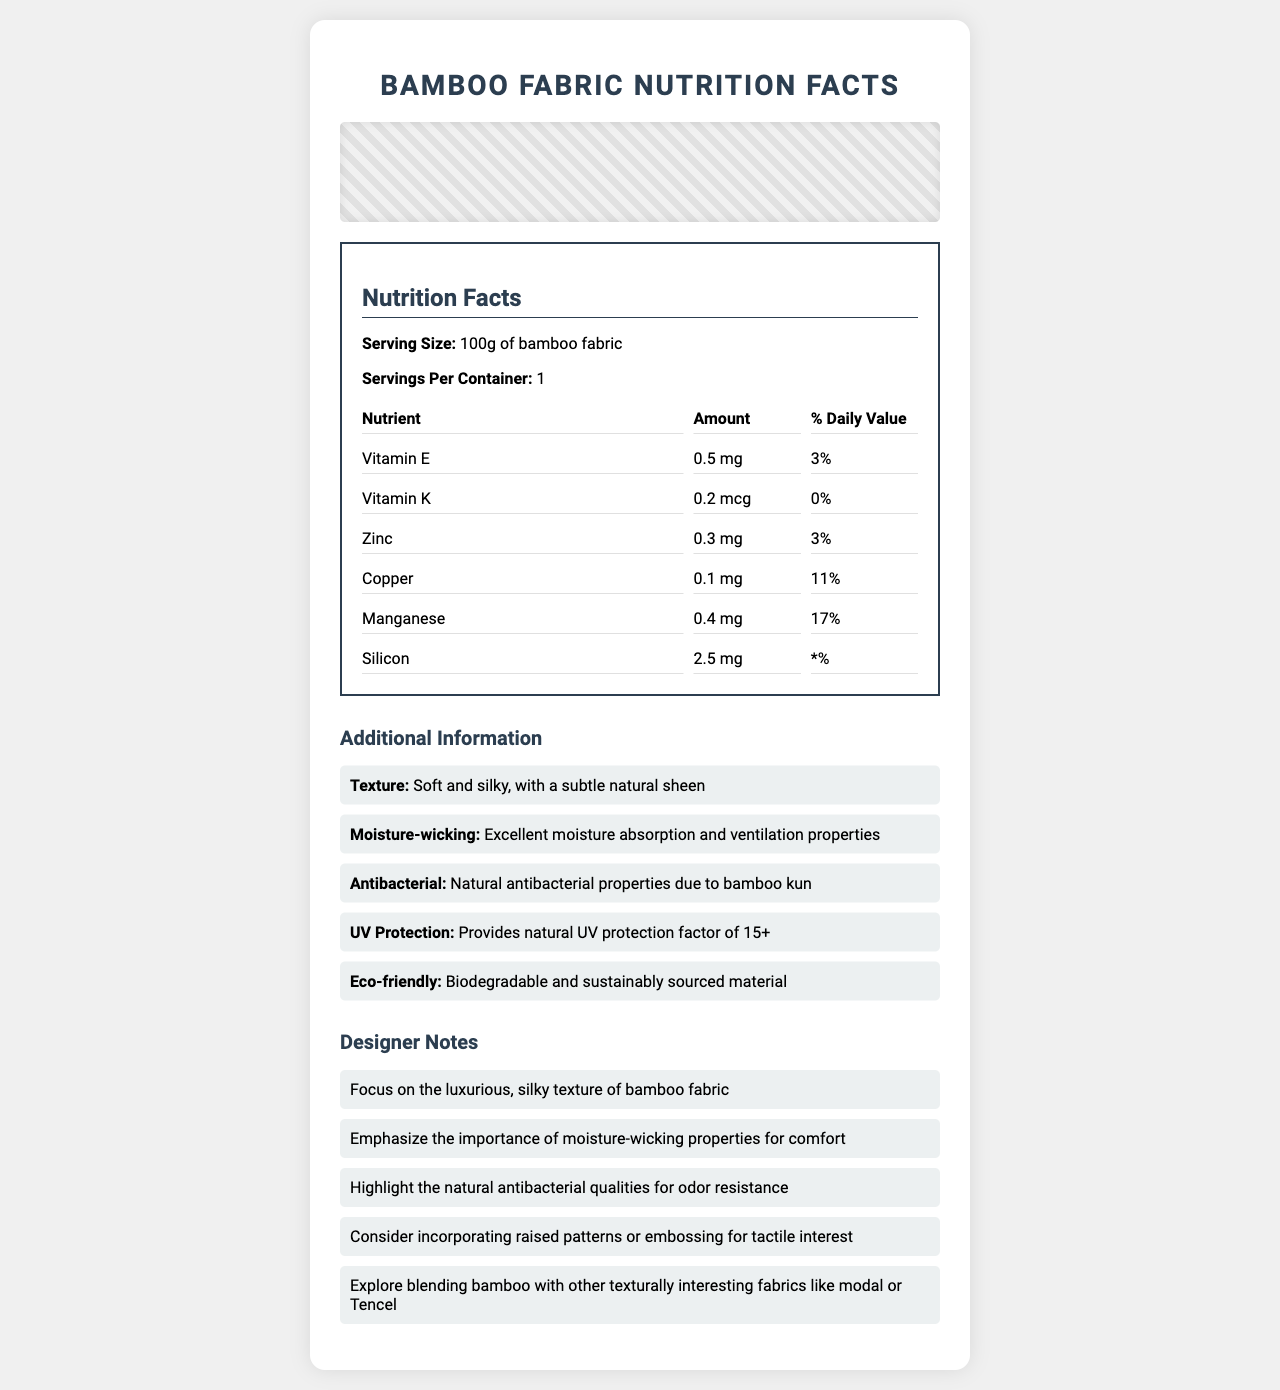what is the serving size specified on the label? The serving size is explicitly mentioned as "100g of bamboo fabric" under the Nutrition Facts section.
Answer: 100g of bamboo fabric how many vitamins are listed on the nutrition label? The document lists two vitamins: Vitamin E and Vitamin K.
Answer: Two what is the daily value percentage of Copper? The daily value percentage of Copper is listed as 11% in the Nutrition Facts section.
Answer: 11% List all the additional information provided in the document. The additional information section provides these details: Texture: Soft and silky, with a subtle natural sheen; Moisture-wicking: Excellent moisture absorption and ventilation properties; Antibacterial: Natural antibacterial properties due to bamboo kun; UV Protection: Provides natural UV protection factor of 15+; and Eco-friendly: Biodegradable and sustainably sourced material.
Answer: Texture: Soft and silky, with a subtle natural sheen; Moisture-wicking: Excellent moisture absorption and ventilation properties; Antibacterial: Natural antibacterial properties due to bamboo kun; UV Protection: Provides natural UV protection factor of 15+; Eco-friendly: Biodegradable and sustainably sourced material what is the amount of Silicon in the fabric? The document lists the amount of Silicon as 2.5 mg.
Answer: 2.5 mg how many servings per container are mentioned? There is 1 serving per container as mentioned in the Nutrition Facts section.
Answer: 1 What are the antibacterial properties attributed to in the fabric? A. Moisture absorption B. Bamboo kun C. Silicon D. UV protection The document specifies that the natural antibacterial properties are due to bamboo kun.
Answer: B. Bamboo kun Which nutrient has the highest daily value percentage listed? A. Vitamin E B. Zinc C. Manganese D. Copper Among the listed nutrients, Manganese has the highest daily value percentage at 17%.
Answer: C. Manganese Is there any information about fiber content in the document? The document does not mention fiber content.
Answer: No Summarize the main features highlighted about the bamboo fabric in the document. The main features of the bamboo fabric include nutritional content, texture, moisture-wicking abilities, antibacterial properties, UV protection, and eco-friendliness. Designer notes emphasize texture and blending with other interesting fabrics.
Answer: The document highlights the following features about the bamboo fabric: nutritional facts including various vitamins and minerals, additional information like texture, moisture-wicking, antibacterial properties, UV protection, and eco-friendly aspects. It also includes designer notes emphasizing texture, moisture-wicking, antibacterial qualities, and blending with other fabrics. What percentage of daily value does Zinc contribute? The document lists Zinc with a 3% daily value.
Answer: 3% What is one of the designer notes mentioned? One of the designer notes says to focus on the luxurious, silky texture of the bamboo fabric.
Answer: Focus on the luxurious, silky texture of bamboo fabric Can you determine the environmental impact of producing the fabric based on the provided document? The document does not provide specific details regarding the environmental impact of its production, only that the fabric is biodegradable and sustainably sourced.
Answer: Cannot be determined 